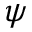<formula> <loc_0><loc_0><loc_500><loc_500>\psi</formula> 